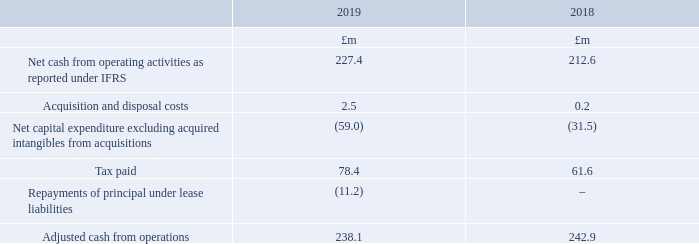Adjusted cash flow
A reconciliation showing the items that bridge between net cash from operating activities as reported under IFRS to an adjusted basis is given below. Adjusted cash from operations is used by the Board to monitor the performance of the Group, with a focus on elements of cashflow, such as Net capital expenditure, which are subject to day to day control by the business.
Adjusted cash conversion in 2019 is 84% (2018: 91%). Cash conversion is calculated as adjusted cash from operations divided by adjusted operating profit.
The adjusted cash flow is included in the Financial Review on page 58.
What does the Board use Adjusted cash from operations for? To monitor the performance of the group, with a focus on elements of cashflow, such as net capital expenditure, which are subject to day to day control by the business. How is cash conversion calculated? As adjusted cash from operations divided by adjusted operating profit. In which years was the adjusted cash conversion calculated in? 2019, 2018. In which year was the adjusted cash from operations larger? 242.9>238.1
Answer: 2018. What was the percentage change in the adjusted cash conversion in 2019 from 2018?
Answer scale should be: percent. 91%-84%
Answer: 7. What was the percentage change in the amount of tax paid in 2019 from 2018?
Answer scale should be: percent. (78.4-61.6)/61.6
Answer: 27.27. 